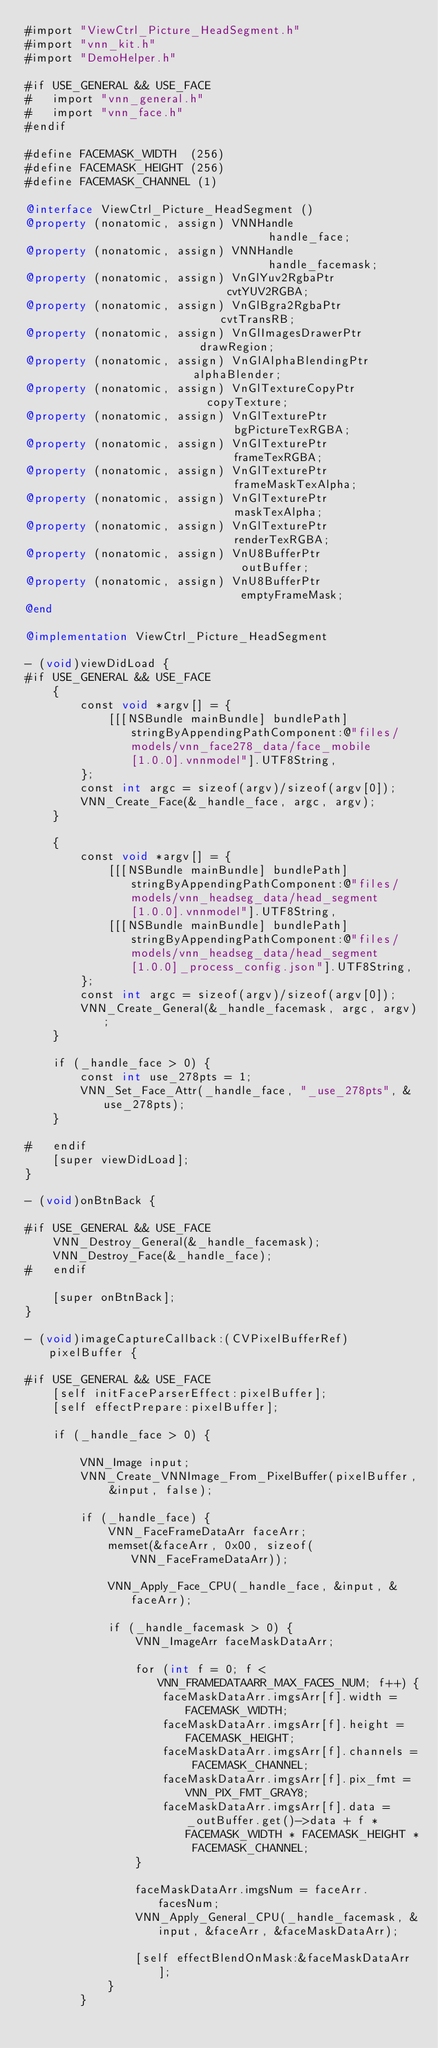<code> <loc_0><loc_0><loc_500><loc_500><_ObjectiveC_>#import "ViewCtrl_Picture_HeadSegment.h"
#import "vnn_kit.h"
#import "DemoHelper.h"

#if USE_GENERAL && USE_FACE
#   import "vnn_general.h"
#   import "vnn_face.h"
#endif

#define FACEMASK_WIDTH  (256)
#define FACEMASK_HEIGHT (256)
#define FACEMASK_CHANNEL (1)

@interface ViewCtrl_Picture_HeadSegment ()
@property (nonatomic, assign) VNNHandle                                 handle_face;
@property (nonatomic, assign) VNNHandle                                 handle_facemask;
@property (nonatomic, assign) VnGlYuv2RgbaPtr                           cvtYUV2RGBA;
@property (nonatomic, assign) VnGlBgra2RgbaPtr                          cvtTransRB;
@property (nonatomic, assign) VnGlImagesDrawerPtr                       drawRegion;
@property (nonatomic, assign) VnGlAlphaBlendingPtr                      alphaBlender;
@property (nonatomic, assign) VnGlTextureCopyPtr                        copyTexture;
@property (nonatomic, assign) VnGlTexturePtr                            bgPictureTexRGBA;
@property (nonatomic, assign) VnGlTexturePtr                            frameTexRGBA;
@property (nonatomic, assign) VnGlTexturePtr                            frameMaskTexAlpha;
@property (nonatomic, assign) VnGlTexturePtr                            maskTexAlpha;
@property (nonatomic, assign) VnGlTexturePtr                            renderTexRGBA;
@property (nonatomic, assign) VnU8BufferPtr                             outBuffer;
@property (nonatomic, assign) VnU8BufferPtr                             emptyFrameMask;
@end

@implementation ViewCtrl_Picture_HeadSegment

- (void)viewDidLoad {
#if USE_GENERAL && USE_FACE
    {
        const void *argv[] = {
            [[[NSBundle mainBundle] bundlePath] stringByAppendingPathComponent:@"files/models/vnn_face278_data/face_mobile[1.0.0].vnnmodel"].UTF8String,
        };
        const int argc = sizeof(argv)/sizeof(argv[0]);
        VNN_Create_Face(&_handle_face, argc, argv);
    }
    
    {
        const void *argv[] = {
            [[[NSBundle mainBundle] bundlePath] stringByAppendingPathComponent:@"files/models/vnn_headseg_data/head_segment[1.0.0].vnnmodel"].UTF8String,
            [[[NSBundle mainBundle] bundlePath] stringByAppendingPathComponent:@"files/models/vnn_headseg_data/head_segment[1.0.0]_process_config.json"].UTF8String,
        };
        const int argc = sizeof(argv)/sizeof(argv[0]);
        VNN_Create_General(&_handle_facemask, argc, argv);
    }
    
    if (_handle_face > 0) {
        const int use_278pts = 1;
        VNN_Set_Face_Attr(_handle_face, "_use_278pts", &use_278pts);
    }
    
#   endif
    [super viewDidLoad];
}

- (void)onBtnBack {
    
#if USE_GENERAL && USE_FACE
    VNN_Destroy_General(&_handle_facemask);
    VNN_Destroy_Face(&_handle_face);
#   endif
    
    [super onBtnBack];
}

- (void)imageCaptureCallback:(CVPixelBufferRef)pixelBuffer {
    
#if USE_GENERAL && USE_FACE
    [self initFaceParserEffect:pixelBuffer];
    [self effectPrepare:pixelBuffer];
    
    if (_handle_face > 0) {
        
        VNN_Image input;
        VNN_Create_VNNImage_From_PixelBuffer(pixelBuffer, &input, false);
        
        if (_handle_face) {
            VNN_FaceFrameDataArr faceArr;
            memset(&faceArr, 0x00, sizeof(VNN_FaceFrameDataArr));
            
            VNN_Apply_Face_CPU(_handle_face, &input, &faceArr);
            
            if (_handle_facemask > 0) {
                VNN_ImageArr faceMaskDataArr;
                
                for (int f = 0; f < VNN_FRAMEDATAARR_MAX_FACES_NUM; f++) {
                    faceMaskDataArr.imgsArr[f].width = FACEMASK_WIDTH;
                    faceMaskDataArr.imgsArr[f].height = FACEMASK_HEIGHT;
                    faceMaskDataArr.imgsArr[f].channels = FACEMASK_CHANNEL;
                    faceMaskDataArr.imgsArr[f].pix_fmt = VNN_PIX_FMT_GRAY8;
                    faceMaskDataArr.imgsArr[f].data = _outBuffer.get()->data + f * FACEMASK_WIDTH * FACEMASK_HEIGHT * FACEMASK_CHANNEL;
                }
                
                faceMaskDataArr.imgsNum = faceArr.facesNum;
                VNN_Apply_General_CPU(_handle_facemask, &input, &faceArr, &faceMaskDataArr);
                
                [self effectBlendOnMask:&faceMaskDataArr];
            }
        }</code> 